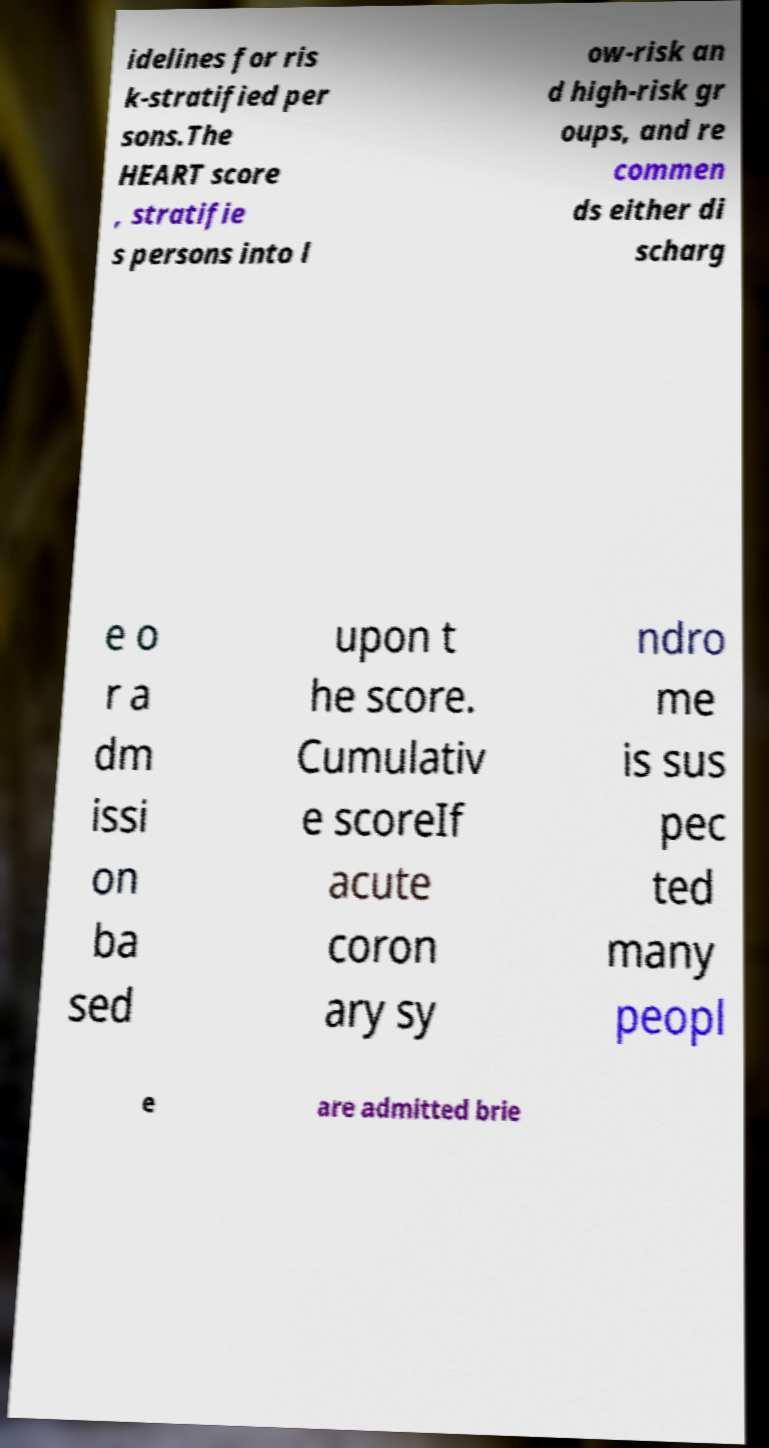Could you extract and type out the text from this image? idelines for ris k-stratified per sons.The HEART score , stratifie s persons into l ow-risk an d high-risk gr oups, and re commen ds either di scharg e o r a dm issi on ba sed upon t he score. Cumulativ e scoreIf acute coron ary sy ndro me is sus pec ted many peopl e are admitted brie 